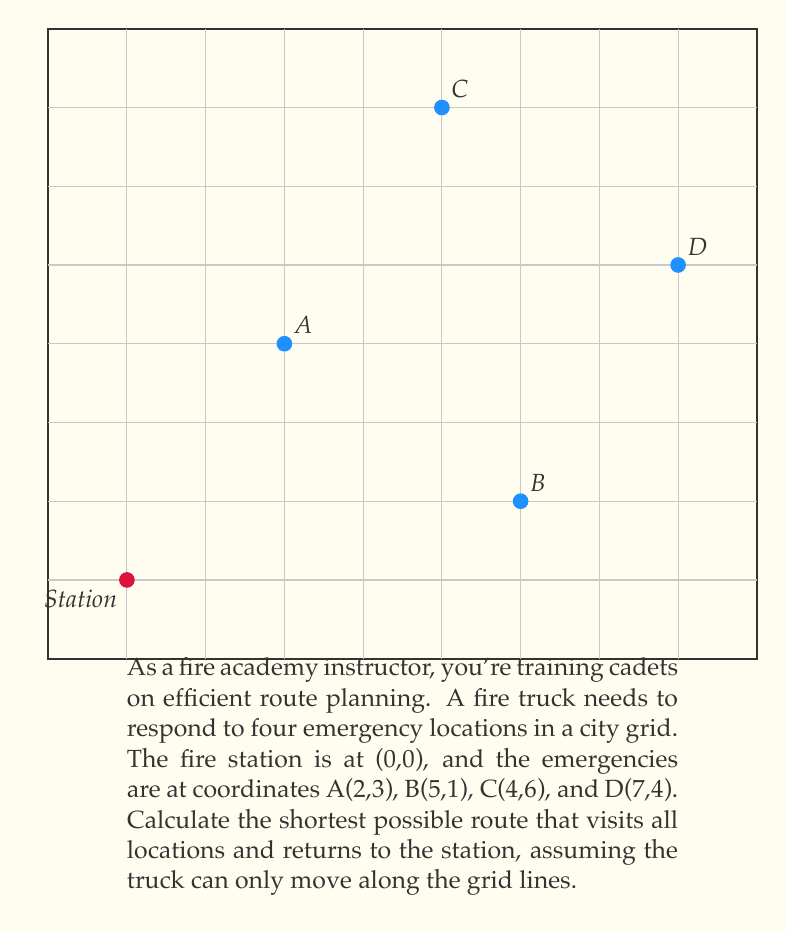Show me your answer to this math problem. To solve this problem, we'll use the concept of the Traveling Salesman Problem (TSP) adapted to a grid system. Here's a step-by-step approach:

1) First, calculate the Manhattan distances between all points:
   - Station to A: $|0-2| + |0-3| = 5$
   - Station to B: $|0-5| + |0-1| = 6$
   - Station to C: $|0-4| + |0-6| = 10$
   - Station to D: $|0-7| + |0-4| = 11$
   - A to B: $|2-5| + |3-1| = 5$
   - A to C: $|2-4| + |3-6| = 5$
   - A to D: $|2-7| + |3-4| = 6$
   - B to C: $|5-4| + |1-6| = 6$
   - B to D: $|5-7| + |1-4| = 5$
   - C to D: $|4-7| + |6-4| = 5$

2) With only 5 points (including the station), we can use brute force to check all possible routes. There are 4! = 24 possible routes.

3) Calculate the total distance for each route. Here are a few examples:
   - Station -> A -> B -> C -> D -> Station: $5 + 5 + 6 + 5 + 11 = 32$
   - Station -> A -> C -> B -> D -> Station: $5 + 5 + 6 + 5 + 11 = 32$
   - Station -> B -> A -> C -> D -> Station: $6 + 5 + 5 + 5 + 11 = 32$

4) After checking all routes, we find that several routes tie for the shortest distance of 32 units.

5) One of the optimal routes is: Station -> A -> C -> D -> B -> Station

This route minimizes backtracking and uses the grid structure efficiently.
Answer: 32 units; Station -> A -> C -> D -> B -> Station 